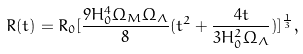Convert formula to latex. <formula><loc_0><loc_0><loc_500><loc_500>R ( t ) = R _ { 0 } [ \frac { 9 H _ { 0 } ^ { 4 } \Omega _ { M } \Omega _ { \Lambda } } { 8 } ( t ^ { 2 } + \frac { 4 t } { 3 H _ { 0 } ^ { 2 } \Omega _ { \Lambda } } ) ] ^ { \frac { 1 } { 3 } } ,</formula> 